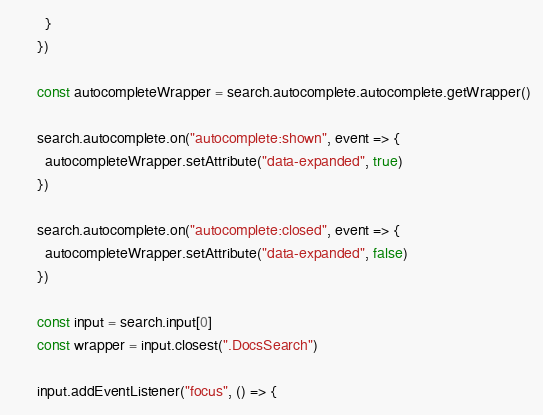Convert code to text. <code><loc_0><loc_0><loc_500><loc_500><_JavaScript_>        }
      })

      const autocompleteWrapper = search.autocomplete.autocomplete.getWrapper()

      search.autocomplete.on("autocomplete:shown", event => {
        autocompleteWrapper.setAttribute("data-expanded", true)
      })

      search.autocomplete.on("autocomplete:closed", event => {
        autocompleteWrapper.setAttribute("data-expanded", false)
      })

      const input = search.input[0]
      const wrapper = input.closest(".DocsSearch")

      input.addEventListener("focus", () => {</code> 